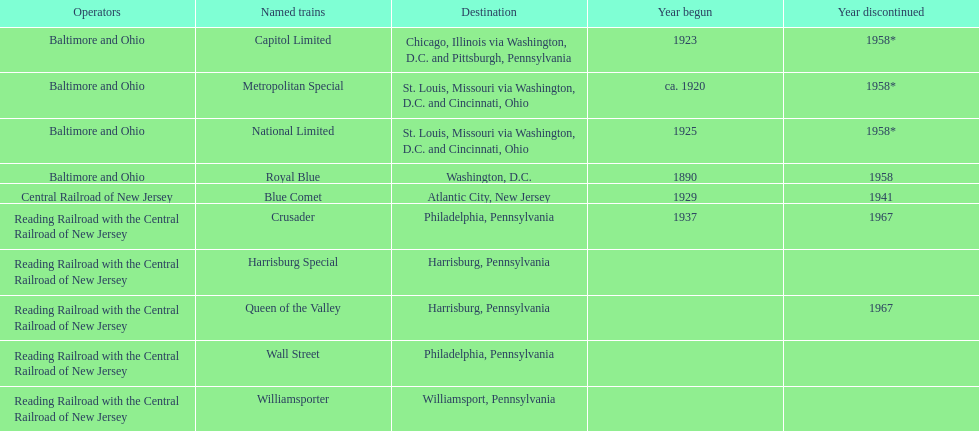Which other traine, other than wall street, had philadelphia as a destination? Crusader. 